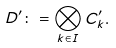<formula> <loc_0><loc_0><loc_500><loc_500>D ^ { \prime } \colon = \bigotimes _ { k \in I } C ^ { \prime } _ { k } .</formula> 